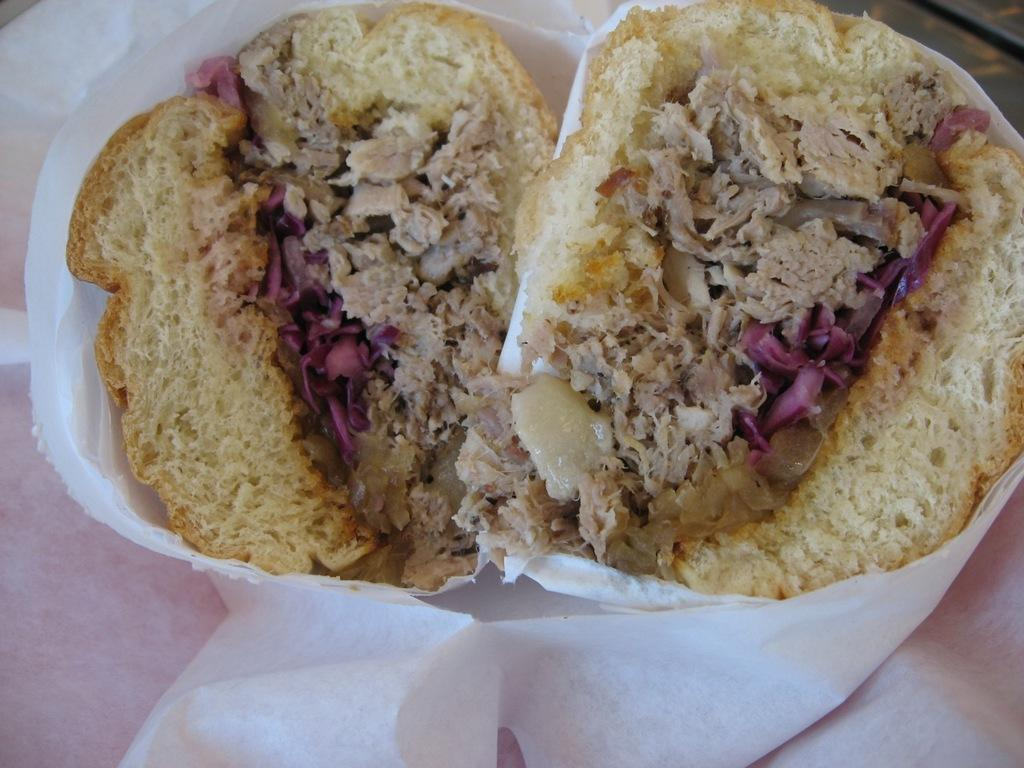What type of container is visible in the image? There is a paper cup in the image. What is inside the paper cup? The paper cup contains two bread slices, a vegetable mixture, and a meat mixture. How does the smoke affect the time in the image? There is no smoke present in the image, so it cannot affect the time. 